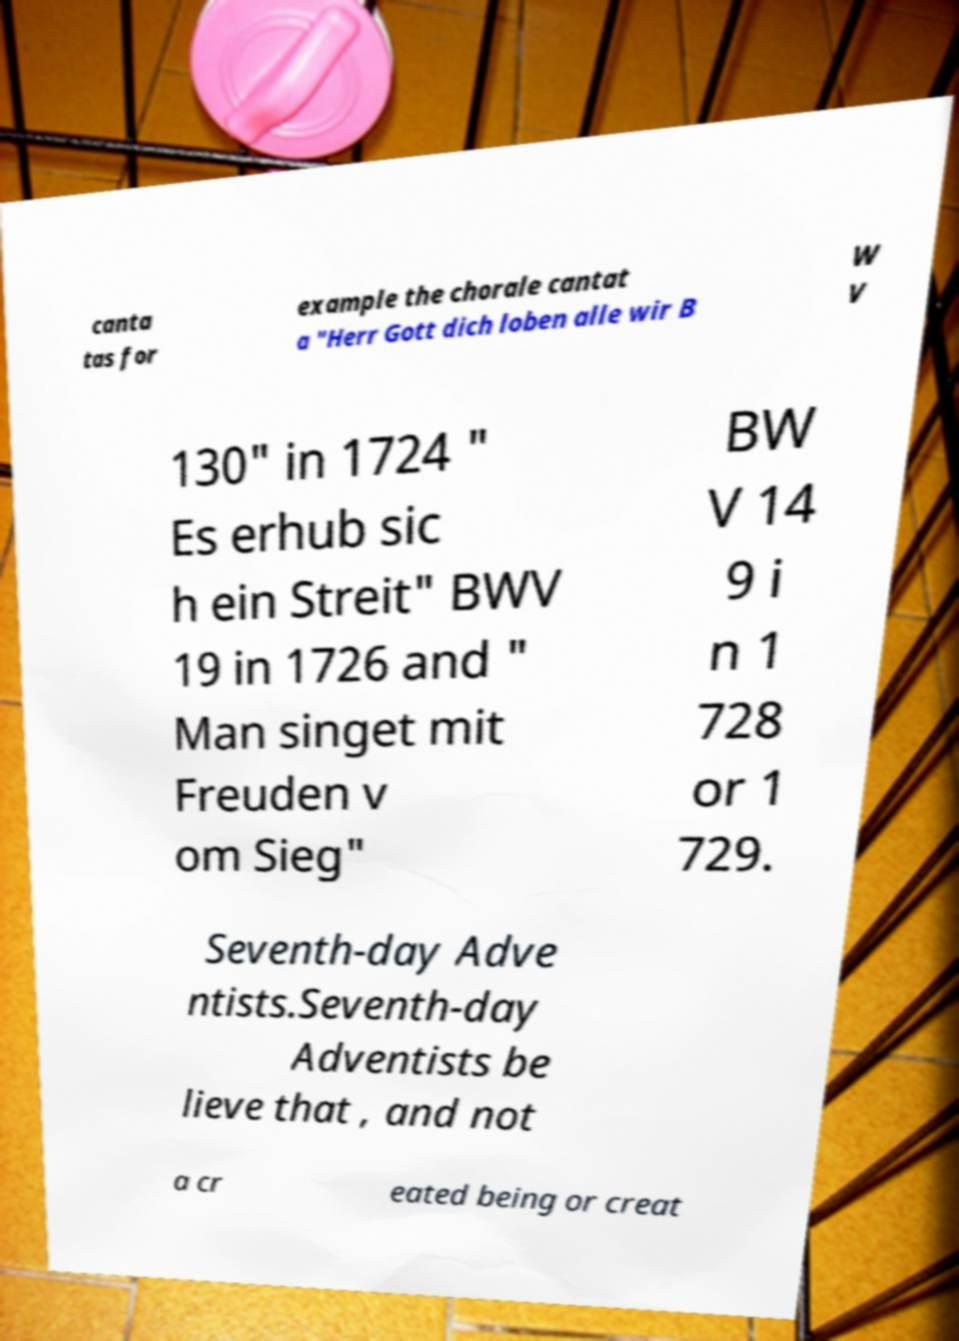Can you read and provide the text displayed in the image?This photo seems to have some interesting text. Can you extract and type it out for me? canta tas for example the chorale cantat a "Herr Gott dich loben alle wir B W V 130" in 1724 " Es erhub sic h ein Streit" BWV 19 in 1726 and " Man singet mit Freuden v om Sieg" BW V 14 9 i n 1 728 or 1 729. Seventh-day Adve ntists.Seventh-day Adventists be lieve that , and not a cr eated being or creat 